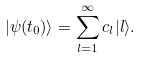Convert formula to latex. <formula><loc_0><loc_0><loc_500><loc_500>| \psi ( t _ { 0 } ) \rangle = \sum _ { l = 1 } ^ { \infty } c _ { l } | l \rangle .</formula> 